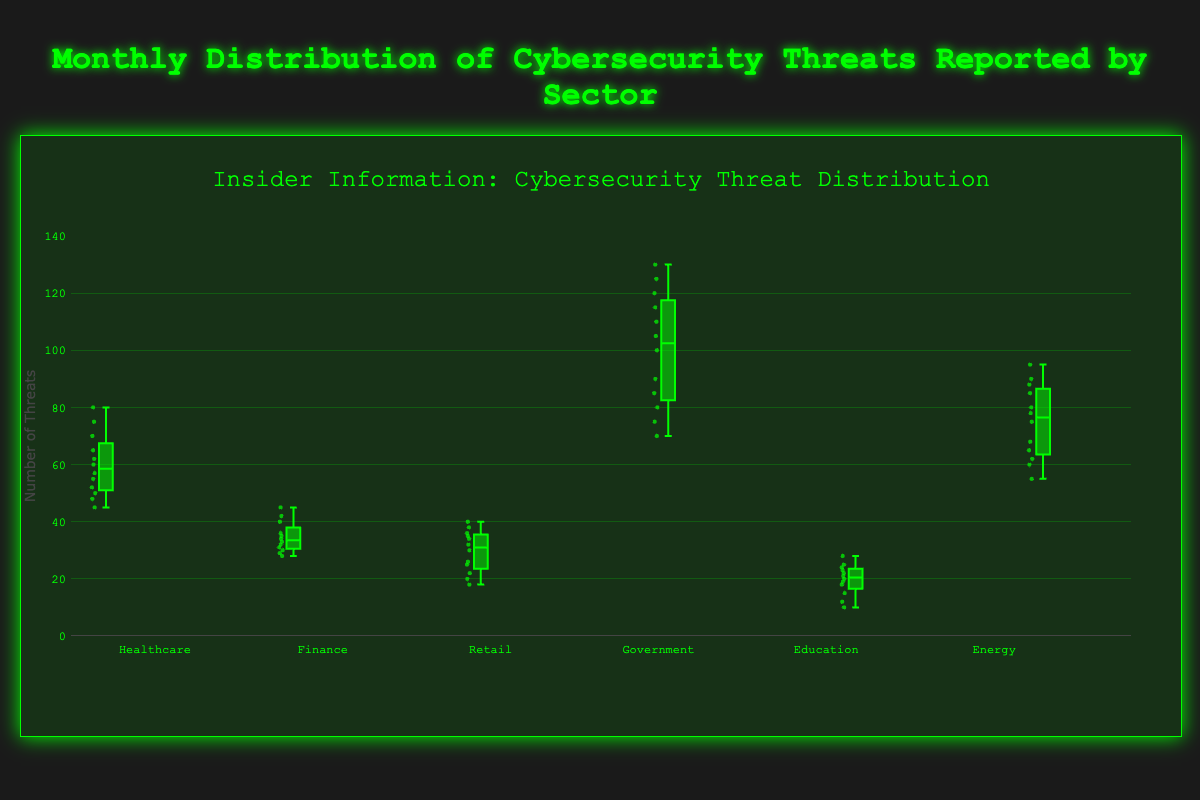1. What is the title of the box plot? The title is displayed at the top of the plotting area. It provides context about what the box plot represents.
Answer: Insider Information: Cybersecurity Threat Distribution 2. How many sectors are compared in the box plot? The number of sectors can be counted by looking at the distinct labels on the x-axis. Each box represents a different sector.
Answer: 6 3. Which sector has the widest range of monthly cybersecurity threats reported? The range is the difference between the maximum and minimum values for each sector. Compare these ranges across all sectors.
Answer: Government 4. What is the median number of threats for the Finance sector? Locate the center line within the box plot for the Finance sector which represents the median value.
Answer: 34 5. Which sector has the highest median number of cybersecurity threats reported? Identify and compare the median lines of all the sectors. The highest median line indicates the sector with the highest median number of threats.
Answer: Government 6. What is the interquartile range (IQR) of monthly threats in the Healthcare sector? IQR is the difference between the third quartile (75th percentile) and the first quartile (25th percentile), seen as the top and bottom edges of the box.
Answer: 20 7. Among all the sectors shown, which one has the smallest spread of monthly threats? The smallest spread is indicated by the narrowest box and the shortest whiskers, showing less variability.
Answer: Retail 8. Compare the third quartile (75th percentile) of the Education sector to the median of the Healthcare sector. Which is higher? Find the third quartile of Education and compare it to the median value of Healthcare.
Answer: Median of Healthcare 9. Which sector shows the most outliers? Count the number of individual points outside the whiskers for each sector. The sector with the most points is the one with the most outliers.
Answer: Government 10. Is there any sector where the median value is below 20 monthly threats? If yes, which one? Locate the median values for each sector and check if any are below 20.
Answer: Education 